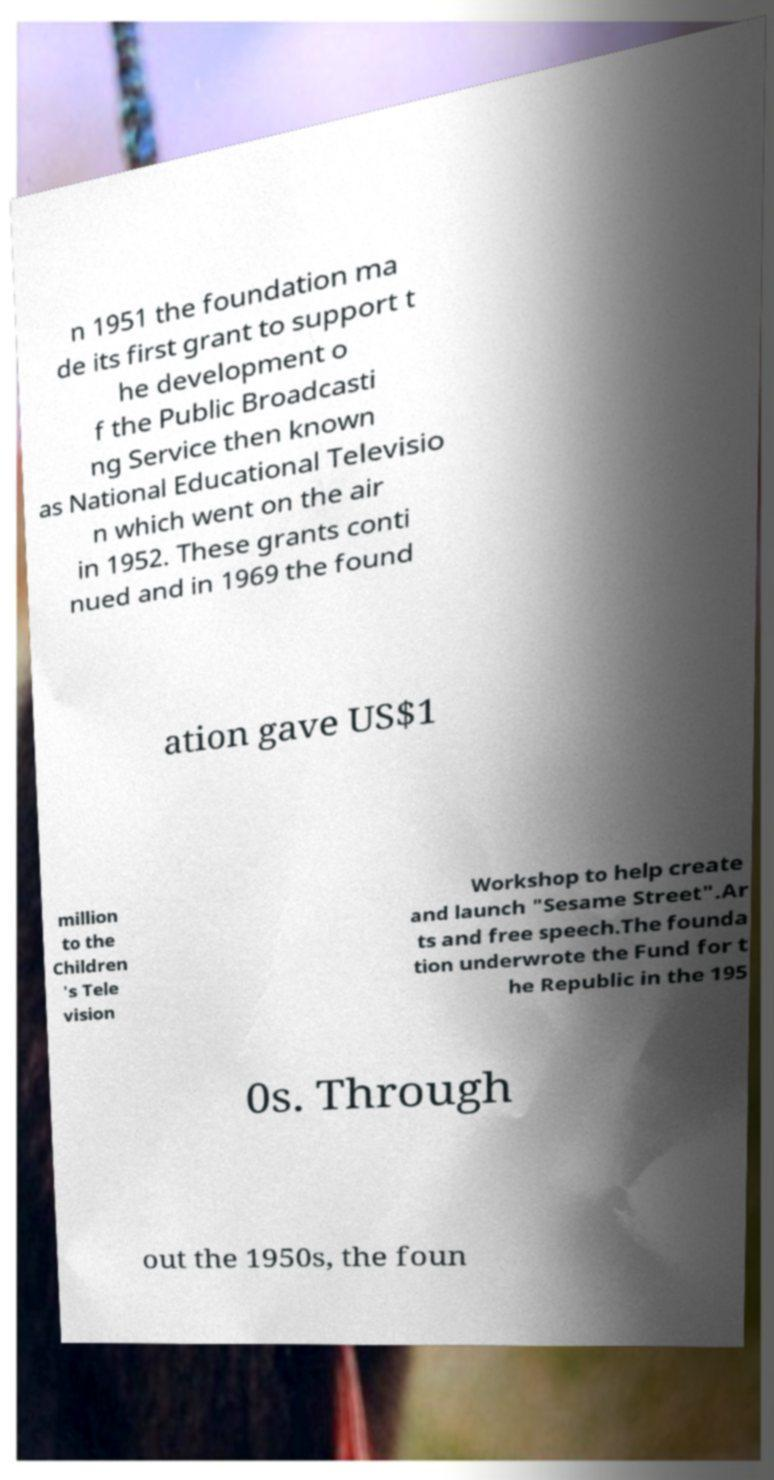Please identify and transcribe the text found in this image. n 1951 the foundation ma de its first grant to support t he development o f the Public Broadcasti ng Service then known as National Educational Televisio n which went on the air in 1952. These grants conti nued and in 1969 the found ation gave US$1 million to the Children 's Tele vision Workshop to help create and launch "Sesame Street".Ar ts and free speech.The founda tion underwrote the Fund for t he Republic in the 195 0s. Through out the 1950s, the foun 